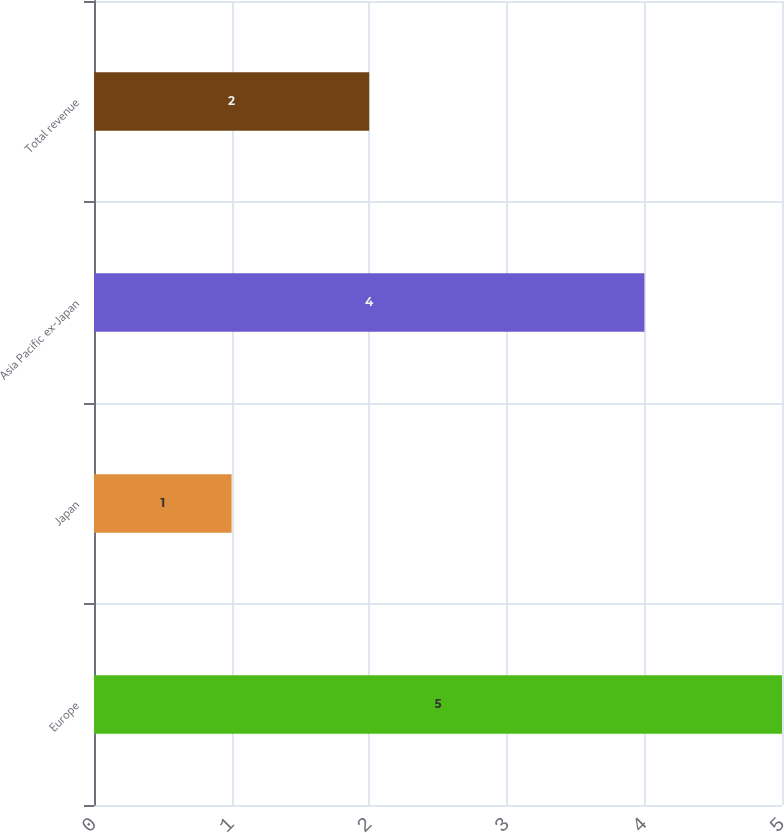<chart> <loc_0><loc_0><loc_500><loc_500><bar_chart><fcel>Europe<fcel>Japan<fcel>Asia Pacific ex-Japan<fcel>Total revenue<nl><fcel>5<fcel>1<fcel>4<fcel>2<nl></chart> 